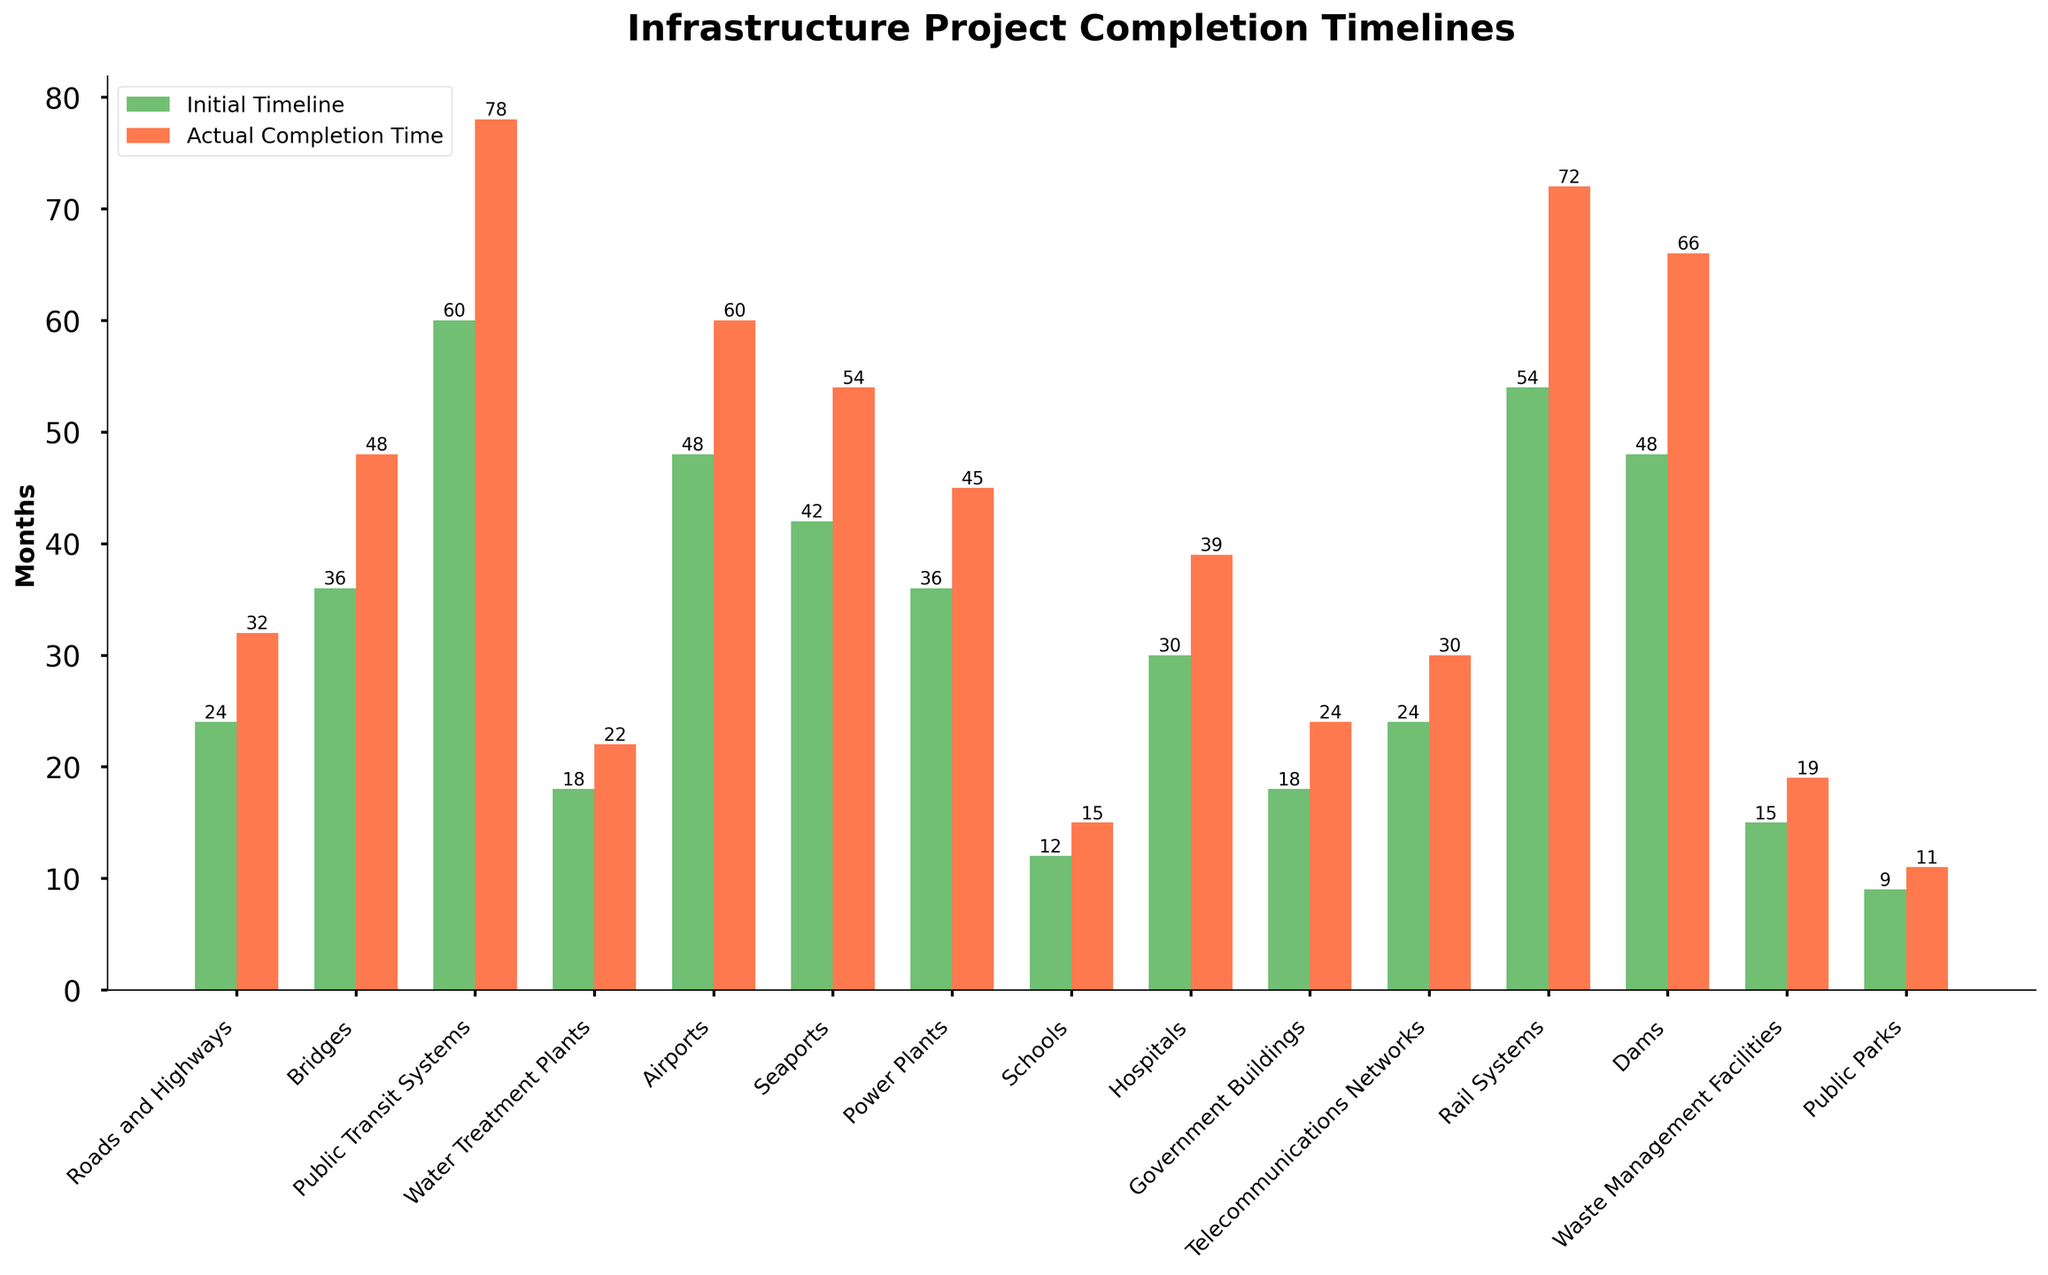Which project type has the largest difference between the initial timeline and actual completion time? To determine the project type with the largest difference, we need to subtract the initial timeline from the actual completion time for each project type. The differences are: Roads and Highways (8), Bridges (12), Public Transit Systems (18), Water Treatment Plants (4), Airports (12), Seaports (12), Power Plants (9), Schools (3), Hospitals (9), Government Buildings (6), Telecommunications Networks (6), Rail Systems (18), Dams (18), Waste Management Facilities (4), Public Parks (2). The largest differences are for Public Transit Systems, Rail Systems, and Dams, each with a difference of 18 months.
Answer: Public Transit Systems, Rail Systems, Dams What is the average initial timeline for all the projects? To find the average initial timeline, sum all initial timelines and divide by the total number of project types: (24 + 36 + 60 + 18 + 48 + 42 + 36 + 12 + 30 + 18 + 24 + 54 + 48 + 15 + 9) / 15 = 474 / 15 = 31.6 months.
Answer: 31.6 months Which project type was completed in the least amount of time compared to the initial timeline? We can determine this by identifying the project type with the smallest difference between the initial timeline and actual completion time. Calculating the differences: Roads and Highways (8), Bridges (12), Public Transit Systems (18), Water Treatment Plants (4), Airports (12), Seaports (12), Power Plants (9), Schools (3), Hospitals (9), Government Buildings (6), Telecommunications Networks (6), Rail Systems (18), Dams (18), Waste Management Facilities (4), Public Parks (2). The smallest difference is for Public Parks, with a difference of 2 months.
Answer: Public Parks What visual difference can be observed between the bars representing the initial and actual timelines? The initial timeline bars are green, while the actual completion time bars are red. The red bars are consistently taller than the green bars for all project types, indicating that the actual completion times exceed the initial timelines.
Answer: The red bars are taller For which project types do the actual completion times exceed the initial timelines by more than 12 months? We need to check for project types where the difference between actual completion time and initial timeline is more than 12 months. These projects are: Public Transit Systems (18 months), Rail Systems (18 months), Dams (18 months).
Answer: Public Transit Systems, Rail Systems, Dams How many project types have an initial timeline of less than 20 months? Counting the projects with an initial timeline under 20 months: Water Treatment Plants (18), Schools (12), Government Buildings (18), Waste Management Facilities (15), Public Parks (9). There are 5 project types that meet this criterion.
Answer: 5 project types 